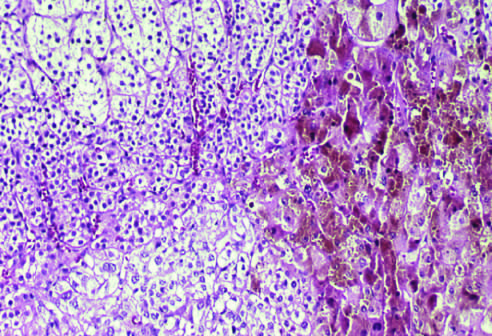re the nodules composed of cells containing lipofuscin pigment, seen in the right part of the field on histologic examination?
Answer the question using a single word or phrase. Yes 